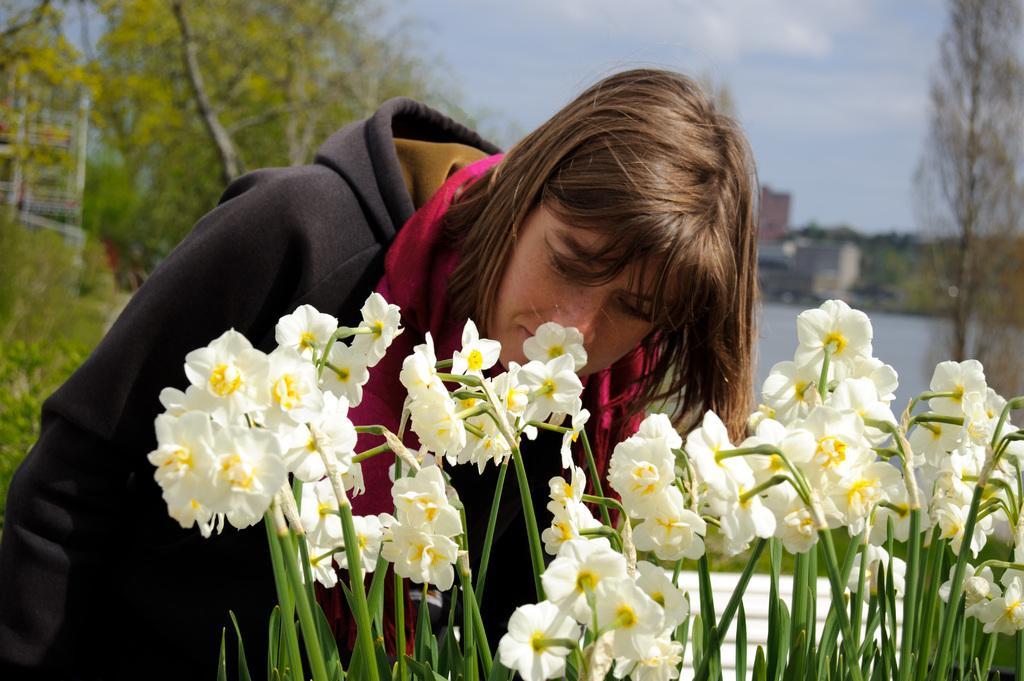How would you summarize this image in a sentence or two? In this image we can see a lady, there are flowers, plants, trees, buildings, also we can see the sky. 